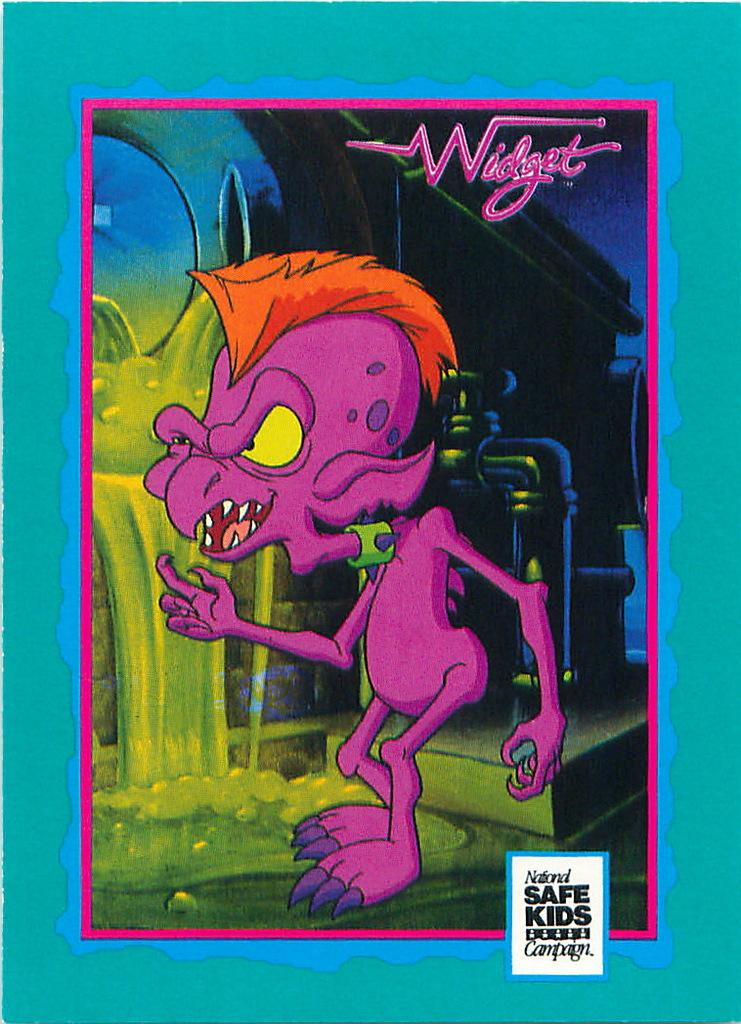<image>
Give a short and clear explanation of the subsequent image. a cartoon character with the name widget on it 